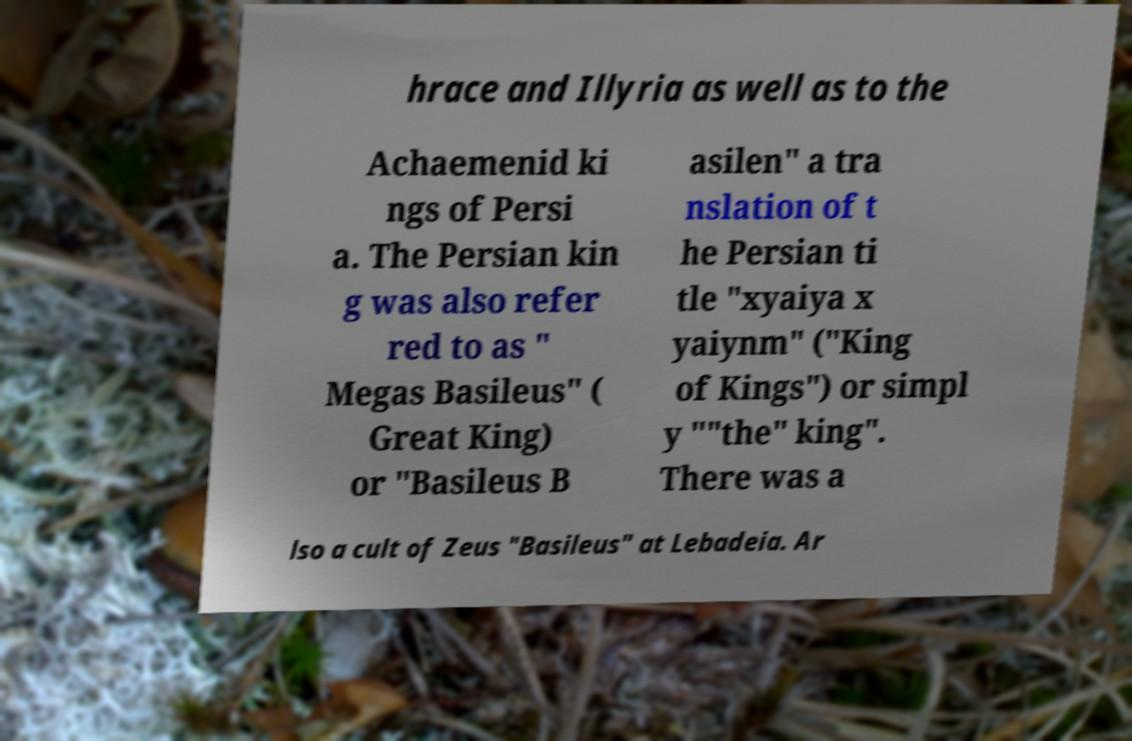For documentation purposes, I need the text within this image transcribed. Could you provide that? hrace and Illyria as well as to the Achaemenid ki ngs of Persi a. The Persian kin g was also refer red to as " Megas Basileus" ( Great King) or "Basileus B asilen" a tra nslation of t he Persian ti tle "xyaiya x yaiynm" ("King of Kings") or simpl y ""the" king". There was a lso a cult of Zeus "Basileus" at Lebadeia. Ar 